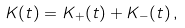Convert formula to latex. <formula><loc_0><loc_0><loc_500><loc_500>K ( t ) = K _ { + } ( t ) + K _ { - } ( t ) \, ,</formula> 